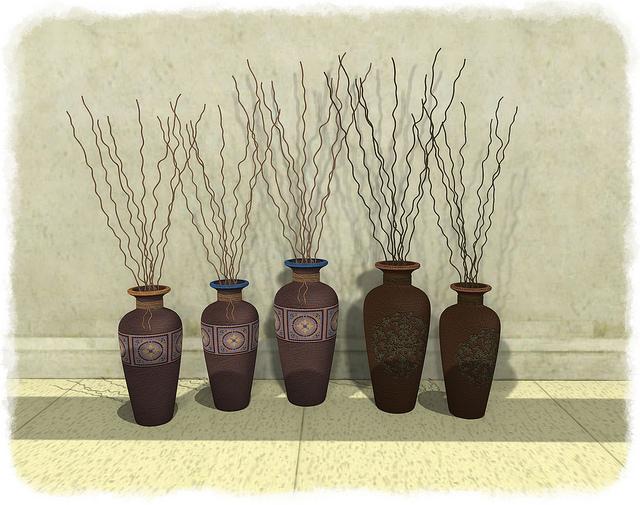How many vases are up against the wall?
Write a very short answer. 5. How many different vase designs are there?
Short answer required. 2. Is this a digitally created image?
Answer briefly. Yes. 